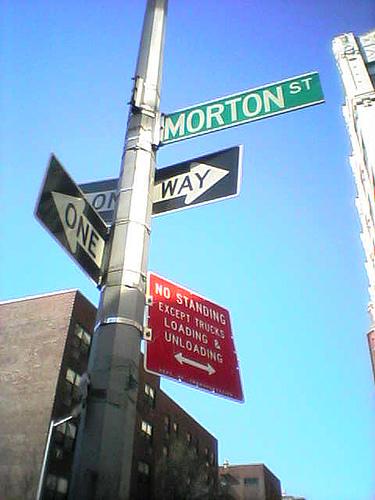How many sign are there?
Quick response, please. 4. Is Morton Street in an industrial area?
Answer briefly. Yes. Where do trucks unload?
Answer briefly. Morton st. 